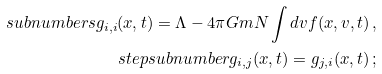<formula> <loc_0><loc_0><loc_500><loc_500>\ s u b n u m b e r s g _ { i , i } ( { x } , t ) = \Lambda - 4 \pi G m N \int d { v } f ( { x } , { v } , t ) \, , \\ \ s t e p s u b n u m b e r g _ { i , j } ( { x } , t ) = g _ { j , i } ( { x } , t ) \, ;</formula> 